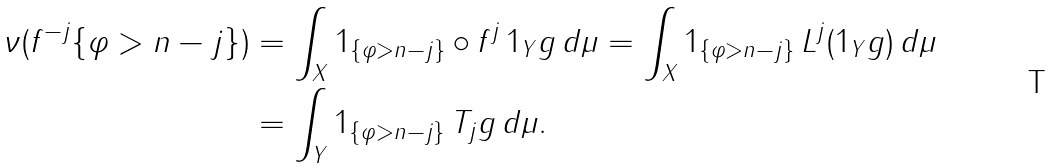Convert formula to latex. <formula><loc_0><loc_0><loc_500><loc_500>\nu ( f ^ { - j } \{ \varphi > n - j \} ) & = \int _ { X } 1 _ { \{ \varphi > n - j \} } \circ f ^ { j } \, 1 _ { Y } g \, d \mu = \int _ { X } 1 _ { \{ \varphi > n - j \} } \, L ^ { j } ( 1 _ { Y } g ) \, d \mu \\ & = \int _ { Y } 1 _ { \{ \varphi > n - j \} } \, T _ { j } g \, d \mu .</formula> 